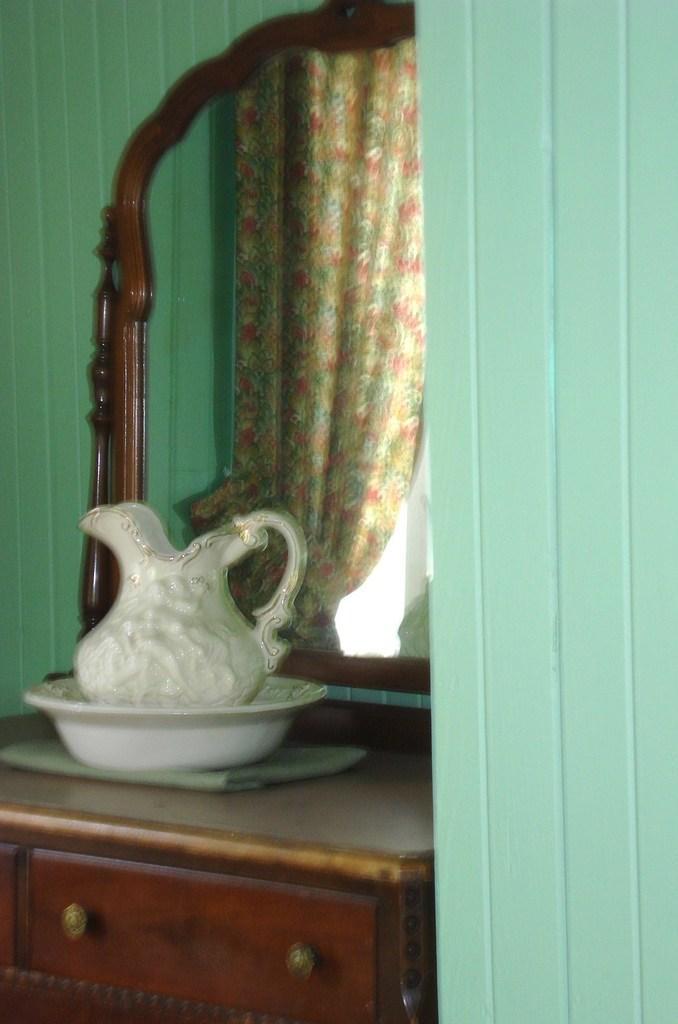Please provide a concise description of this image. In this image we can see a jar in a bowl which is placed on a cupboard. We can also see a mirror and the walls. We can also see a curtain from a mirror. 